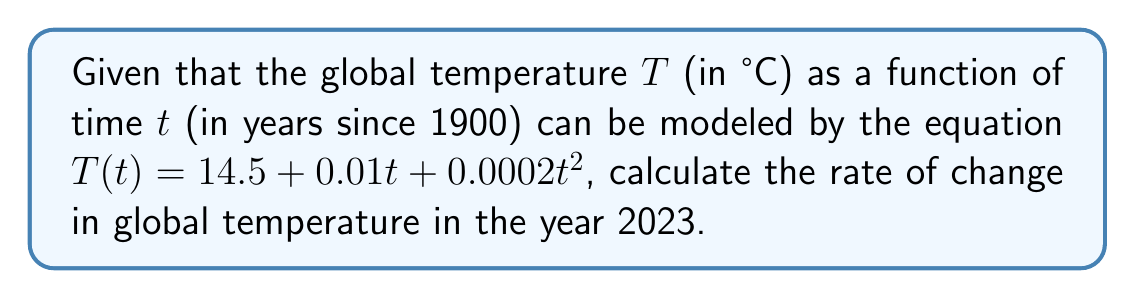Teach me how to tackle this problem. To find the rate of change in global temperature, we need to calculate the derivative of the temperature function $T(t)$ and evaluate it at $t = 2023 - 1900 = 123$ (since $t$ is measured in years since 1900).

Step 1: Calculate the derivative of $T(t)$
$$\frac{dT}{dt} = \frac{d}{dt}(14.5 + 0.01t + 0.0002t^2)$$
$$\frac{dT}{dt} = 0 + 0.01 + 0.0004t$$

Step 2: Simplify the derivative
$$\frac{dT}{dt} = 0.01 + 0.0004t$$

Step 3: Evaluate the derivative at $t = 123$
$$\left.\frac{dT}{dt}\right|_{t=123} = 0.01 + 0.0004(123)$$
$$\left.\frac{dT}{dt}\right|_{t=123} = 0.01 + 0.0492$$
$$\left.\frac{dT}{dt}\right|_{t=123} = 0.0592$$

Step 4: Interpret the result
The rate of change in global temperature in 2023 is 0.0592 °C per year.
Answer: $0.0592$ °C/year 